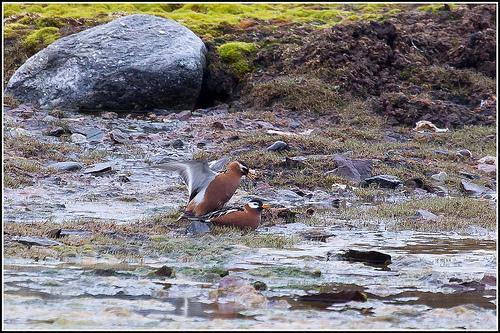How many birds are visible in this photo?
Give a very brief answer. 2. 